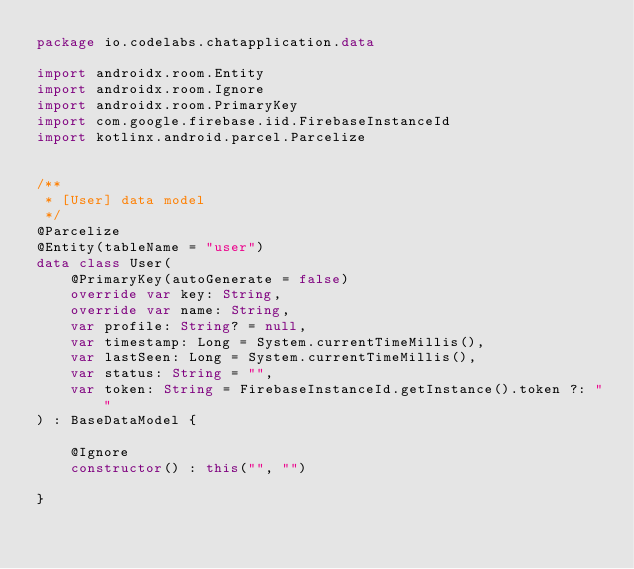Convert code to text. <code><loc_0><loc_0><loc_500><loc_500><_Kotlin_>package io.codelabs.chatapplication.data

import androidx.room.Entity
import androidx.room.Ignore
import androidx.room.PrimaryKey
import com.google.firebase.iid.FirebaseInstanceId
import kotlinx.android.parcel.Parcelize


/**
 * [User] data model
 */
@Parcelize
@Entity(tableName = "user")
data class User(
    @PrimaryKey(autoGenerate = false)
    override var key: String,
    override var name: String,
    var profile: String? = null,
    var timestamp: Long = System.currentTimeMillis(),
    var lastSeen: Long = System.currentTimeMillis(),
    var status: String = "",
    var token: String = FirebaseInstanceId.getInstance().token ?: ""
) : BaseDataModel {

    @Ignore
    constructor() : this("", "")

}

</code> 